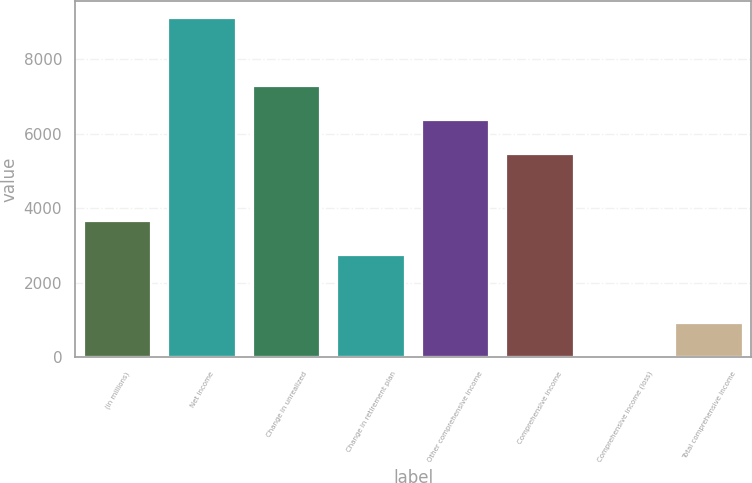Convert chart to OTSL. <chart><loc_0><loc_0><loc_500><loc_500><bar_chart><fcel>(in millions)<fcel>Net income<fcel>Change in unrealized<fcel>Change in retirement plan<fcel>Other comprehensive income<fcel>Comprehensive income<fcel>Comprehensive income (loss)<fcel>Total comprehensive income<nl><fcel>3646.4<fcel>9092<fcel>7276.8<fcel>2738.8<fcel>6369.2<fcel>5461.6<fcel>16<fcel>923.6<nl></chart> 